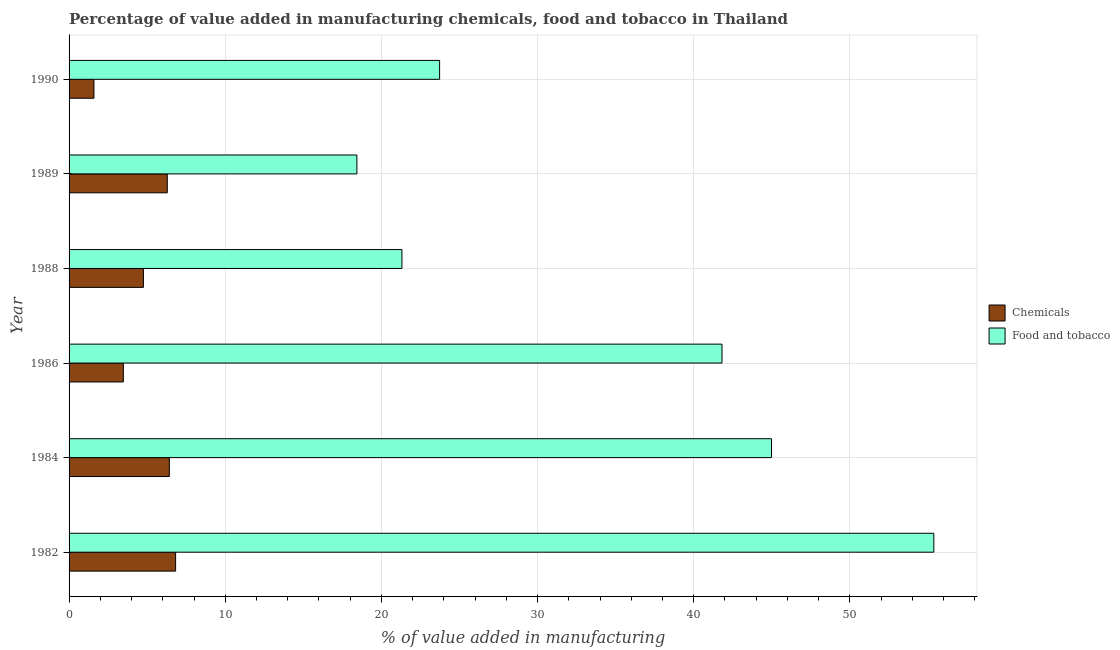How many different coloured bars are there?
Offer a very short reply. 2. Are the number of bars per tick equal to the number of legend labels?
Make the answer very short. Yes. How many bars are there on the 4th tick from the top?
Ensure brevity in your answer.  2. In how many cases, is the number of bars for a given year not equal to the number of legend labels?
Ensure brevity in your answer.  0. What is the value added by manufacturing food and tobacco in 1982?
Make the answer very short. 55.37. Across all years, what is the maximum value added by  manufacturing chemicals?
Keep it short and to the point. 6.82. Across all years, what is the minimum value added by  manufacturing chemicals?
Offer a very short reply. 1.59. In which year was the value added by  manufacturing chemicals maximum?
Offer a terse response. 1982. What is the total value added by  manufacturing chemicals in the graph?
Keep it short and to the point. 29.36. What is the difference between the value added by manufacturing food and tobacco in 1982 and that in 1988?
Provide a succinct answer. 34.06. What is the difference between the value added by manufacturing food and tobacco in 1984 and the value added by  manufacturing chemicals in 1990?
Make the answer very short. 43.39. What is the average value added by  manufacturing chemicals per year?
Ensure brevity in your answer.  4.89. In the year 1988, what is the difference between the value added by  manufacturing chemicals and value added by manufacturing food and tobacco?
Ensure brevity in your answer.  -16.55. What is the ratio of the value added by  manufacturing chemicals in 1986 to that in 1989?
Keep it short and to the point. 0.55. Is the difference between the value added by manufacturing food and tobacco in 1986 and 1988 greater than the difference between the value added by  manufacturing chemicals in 1986 and 1988?
Ensure brevity in your answer.  Yes. What is the difference between the highest and the second highest value added by  manufacturing chemicals?
Give a very brief answer. 0.4. What is the difference between the highest and the lowest value added by manufacturing food and tobacco?
Your answer should be compact. 36.94. Is the sum of the value added by  manufacturing chemicals in 1988 and 1990 greater than the maximum value added by manufacturing food and tobacco across all years?
Give a very brief answer. No. What does the 1st bar from the top in 1982 represents?
Give a very brief answer. Food and tobacco. What does the 2nd bar from the bottom in 1990 represents?
Keep it short and to the point. Food and tobacco. Does the graph contain grids?
Provide a succinct answer. Yes. Where does the legend appear in the graph?
Ensure brevity in your answer.  Center right. How many legend labels are there?
Your answer should be compact. 2. What is the title of the graph?
Provide a short and direct response. Percentage of value added in manufacturing chemicals, food and tobacco in Thailand. What is the label or title of the X-axis?
Your answer should be compact. % of value added in manufacturing. What is the % of value added in manufacturing in Chemicals in 1982?
Offer a terse response. 6.82. What is the % of value added in manufacturing in Food and tobacco in 1982?
Offer a very short reply. 55.37. What is the % of value added in manufacturing in Chemicals in 1984?
Provide a succinct answer. 6.42. What is the % of value added in manufacturing in Food and tobacco in 1984?
Make the answer very short. 44.98. What is the % of value added in manufacturing in Chemicals in 1986?
Your answer should be very brief. 3.48. What is the % of value added in manufacturing of Food and tobacco in 1986?
Your response must be concise. 41.81. What is the % of value added in manufacturing in Chemicals in 1988?
Your answer should be very brief. 4.76. What is the % of value added in manufacturing of Food and tobacco in 1988?
Ensure brevity in your answer.  21.31. What is the % of value added in manufacturing of Chemicals in 1989?
Give a very brief answer. 6.29. What is the % of value added in manufacturing of Food and tobacco in 1989?
Provide a succinct answer. 18.43. What is the % of value added in manufacturing of Chemicals in 1990?
Make the answer very short. 1.59. What is the % of value added in manufacturing in Food and tobacco in 1990?
Provide a succinct answer. 23.73. Across all years, what is the maximum % of value added in manufacturing in Chemicals?
Your answer should be very brief. 6.82. Across all years, what is the maximum % of value added in manufacturing in Food and tobacco?
Give a very brief answer. 55.37. Across all years, what is the minimum % of value added in manufacturing in Chemicals?
Keep it short and to the point. 1.59. Across all years, what is the minimum % of value added in manufacturing in Food and tobacco?
Give a very brief answer. 18.43. What is the total % of value added in manufacturing in Chemicals in the graph?
Your answer should be compact. 29.36. What is the total % of value added in manufacturing in Food and tobacco in the graph?
Make the answer very short. 205.63. What is the difference between the % of value added in manufacturing in Chemicals in 1982 and that in 1984?
Keep it short and to the point. 0.4. What is the difference between the % of value added in manufacturing in Food and tobacco in 1982 and that in 1984?
Provide a short and direct response. 10.39. What is the difference between the % of value added in manufacturing in Chemicals in 1982 and that in 1986?
Offer a very short reply. 3.35. What is the difference between the % of value added in manufacturing of Food and tobacco in 1982 and that in 1986?
Keep it short and to the point. 13.57. What is the difference between the % of value added in manufacturing of Chemicals in 1982 and that in 1988?
Provide a short and direct response. 2.06. What is the difference between the % of value added in manufacturing of Food and tobacco in 1982 and that in 1988?
Make the answer very short. 34.06. What is the difference between the % of value added in manufacturing of Chemicals in 1982 and that in 1989?
Provide a succinct answer. 0.53. What is the difference between the % of value added in manufacturing of Food and tobacco in 1982 and that in 1989?
Provide a succinct answer. 36.94. What is the difference between the % of value added in manufacturing of Chemicals in 1982 and that in 1990?
Offer a terse response. 5.23. What is the difference between the % of value added in manufacturing in Food and tobacco in 1982 and that in 1990?
Your response must be concise. 31.65. What is the difference between the % of value added in manufacturing of Chemicals in 1984 and that in 1986?
Ensure brevity in your answer.  2.94. What is the difference between the % of value added in manufacturing of Food and tobacco in 1984 and that in 1986?
Your response must be concise. 3.17. What is the difference between the % of value added in manufacturing in Chemicals in 1984 and that in 1988?
Offer a very short reply. 1.66. What is the difference between the % of value added in manufacturing in Food and tobacco in 1984 and that in 1988?
Provide a succinct answer. 23.67. What is the difference between the % of value added in manufacturing in Chemicals in 1984 and that in 1989?
Offer a terse response. 0.13. What is the difference between the % of value added in manufacturing in Food and tobacco in 1984 and that in 1989?
Offer a terse response. 26.55. What is the difference between the % of value added in manufacturing in Chemicals in 1984 and that in 1990?
Your answer should be compact. 4.83. What is the difference between the % of value added in manufacturing in Food and tobacco in 1984 and that in 1990?
Offer a terse response. 21.25. What is the difference between the % of value added in manufacturing of Chemicals in 1986 and that in 1988?
Your answer should be compact. -1.28. What is the difference between the % of value added in manufacturing of Food and tobacco in 1986 and that in 1988?
Your answer should be very brief. 20.49. What is the difference between the % of value added in manufacturing of Chemicals in 1986 and that in 1989?
Your response must be concise. -2.81. What is the difference between the % of value added in manufacturing of Food and tobacco in 1986 and that in 1989?
Your response must be concise. 23.38. What is the difference between the % of value added in manufacturing in Chemicals in 1986 and that in 1990?
Keep it short and to the point. 1.88. What is the difference between the % of value added in manufacturing in Food and tobacco in 1986 and that in 1990?
Keep it short and to the point. 18.08. What is the difference between the % of value added in manufacturing of Chemicals in 1988 and that in 1989?
Provide a succinct answer. -1.53. What is the difference between the % of value added in manufacturing in Food and tobacco in 1988 and that in 1989?
Keep it short and to the point. 2.88. What is the difference between the % of value added in manufacturing of Chemicals in 1988 and that in 1990?
Your answer should be very brief. 3.17. What is the difference between the % of value added in manufacturing of Food and tobacco in 1988 and that in 1990?
Make the answer very short. -2.41. What is the difference between the % of value added in manufacturing of Chemicals in 1989 and that in 1990?
Your answer should be very brief. 4.7. What is the difference between the % of value added in manufacturing of Food and tobacco in 1989 and that in 1990?
Your response must be concise. -5.3. What is the difference between the % of value added in manufacturing of Chemicals in 1982 and the % of value added in manufacturing of Food and tobacco in 1984?
Your answer should be compact. -38.16. What is the difference between the % of value added in manufacturing in Chemicals in 1982 and the % of value added in manufacturing in Food and tobacco in 1986?
Your response must be concise. -34.99. What is the difference between the % of value added in manufacturing of Chemicals in 1982 and the % of value added in manufacturing of Food and tobacco in 1988?
Make the answer very short. -14.49. What is the difference between the % of value added in manufacturing in Chemicals in 1982 and the % of value added in manufacturing in Food and tobacco in 1989?
Provide a succinct answer. -11.61. What is the difference between the % of value added in manufacturing in Chemicals in 1982 and the % of value added in manufacturing in Food and tobacco in 1990?
Keep it short and to the point. -16.9. What is the difference between the % of value added in manufacturing of Chemicals in 1984 and the % of value added in manufacturing of Food and tobacco in 1986?
Your response must be concise. -35.39. What is the difference between the % of value added in manufacturing in Chemicals in 1984 and the % of value added in manufacturing in Food and tobacco in 1988?
Provide a short and direct response. -14.89. What is the difference between the % of value added in manufacturing of Chemicals in 1984 and the % of value added in manufacturing of Food and tobacco in 1989?
Offer a very short reply. -12.01. What is the difference between the % of value added in manufacturing in Chemicals in 1984 and the % of value added in manufacturing in Food and tobacco in 1990?
Your response must be concise. -17.31. What is the difference between the % of value added in manufacturing of Chemicals in 1986 and the % of value added in manufacturing of Food and tobacco in 1988?
Give a very brief answer. -17.84. What is the difference between the % of value added in manufacturing of Chemicals in 1986 and the % of value added in manufacturing of Food and tobacco in 1989?
Ensure brevity in your answer.  -14.95. What is the difference between the % of value added in manufacturing in Chemicals in 1986 and the % of value added in manufacturing in Food and tobacco in 1990?
Make the answer very short. -20.25. What is the difference between the % of value added in manufacturing in Chemicals in 1988 and the % of value added in manufacturing in Food and tobacco in 1989?
Offer a terse response. -13.67. What is the difference between the % of value added in manufacturing in Chemicals in 1988 and the % of value added in manufacturing in Food and tobacco in 1990?
Your response must be concise. -18.97. What is the difference between the % of value added in manufacturing of Chemicals in 1989 and the % of value added in manufacturing of Food and tobacco in 1990?
Your answer should be compact. -17.44. What is the average % of value added in manufacturing in Chemicals per year?
Provide a succinct answer. 4.89. What is the average % of value added in manufacturing of Food and tobacco per year?
Your response must be concise. 34.27. In the year 1982, what is the difference between the % of value added in manufacturing of Chemicals and % of value added in manufacturing of Food and tobacco?
Ensure brevity in your answer.  -48.55. In the year 1984, what is the difference between the % of value added in manufacturing in Chemicals and % of value added in manufacturing in Food and tobacco?
Keep it short and to the point. -38.56. In the year 1986, what is the difference between the % of value added in manufacturing in Chemicals and % of value added in manufacturing in Food and tobacco?
Keep it short and to the point. -38.33. In the year 1988, what is the difference between the % of value added in manufacturing of Chemicals and % of value added in manufacturing of Food and tobacco?
Give a very brief answer. -16.55. In the year 1989, what is the difference between the % of value added in manufacturing in Chemicals and % of value added in manufacturing in Food and tobacco?
Keep it short and to the point. -12.14. In the year 1990, what is the difference between the % of value added in manufacturing of Chemicals and % of value added in manufacturing of Food and tobacco?
Provide a succinct answer. -22.13. What is the ratio of the % of value added in manufacturing of Chemicals in 1982 to that in 1984?
Give a very brief answer. 1.06. What is the ratio of the % of value added in manufacturing in Food and tobacco in 1982 to that in 1984?
Your response must be concise. 1.23. What is the ratio of the % of value added in manufacturing in Chemicals in 1982 to that in 1986?
Your answer should be very brief. 1.96. What is the ratio of the % of value added in manufacturing of Food and tobacco in 1982 to that in 1986?
Provide a succinct answer. 1.32. What is the ratio of the % of value added in manufacturing of Chemicals in 1982 to that in 1988?
Keep it short and to the point. 1.43. What is the ratio of the % of value added in manufacturing in Food and tobacco in 1982 to that in 1988?
Give a very brief answer. 2.6. What is the ratio of the % of value added in manufacturing of Chemicals in 1982 to that in 1989?
Provide a short and direct response. 1.08. What is the ratio of the % of value added in manufacturing in Food and tobacco in 1982 to that in 1989?
Make the answer very short. 3. What is the ratio of the % of value added in manufacturing of Chemicals in 1982 to that in 1990?
Offer a terse response. 4.28. What is the ratio of the % of value added in manufacturing of Food and tobacco in 1982 to that in 1990?
Ensure brevity in your answer.  2.33. What is the ratio of the % of value added in manufacturing of Chemicals in 1984 to that in 1986?
Offer a very short reply. 1.85. What is the ratio of the % of value added in manufacturing of Food and tobacco in 1984 to that in 1986?
Provide a succinct answer. 1.08. What is the ratio of the % of value added in manufacturing in Chemicals in 1984 to that in 1988?
Offer a terse response. 1.35. What is the ratio of the % of value added in manufacturing in Food and tobacco in 1984 to that in 1988?
Offer a very short reply. 2.11. What is the ratio of the % of value added in manufacturing of Food and tobacco in 1984 to that in 1989?
Keep it short and to the point. 2.44. What is the ratio of the % of value added in manufacturing of Chemicals in 1984 to that in 1990?
Give a very brief answer. 4.03. What is the ratio of the % of value added in manufacturing in Food and tobacco in 1984 to that in 1990?
Give a very brief answer. 1.9. What is the ratio of the % of value added in manufacturing in Chemicals in 1986 to that in 1988?
Provide a short and direct response. 0.73. What is the ratio of the % of value added in manufacturing in Food and tobacco in 1986 to that in 1988?
Keep it short and to the point. 1.96. What is the ratio of the % of value added in manufacturing of Chemicals in 1986 to that in 1989?
Your answer should be compact. 0.55. What is the ratio of the % of value added in manufacturing of Food and tobacco in 1986 to that in 1989?
Offer a very short reply. 2.27. What is the ratio of the % of value added in manufacturing in Chemicals in 1986 to that in 1990?
Give a very brief answer. 2.18. What is the ratio of the % of value added in manufacturing of Food and tobacco in 1986 to that in 1990?
Your answer should be compact. 1.76. What is the ratio of the % of value added in manufacturing of Chemicals in 1988 to that in 1989?
Your response must be concise. 0.76. What is the ratio of the % of value added in manufacturing of Food and tobacco in 1988 to that in 1989?
Your answer should be very brief. 1.16. What is the ratio of the % of value added in manufacturing in Chemicals in 1988 to that in 1990?
Your answer should be compact. 2.99. What is the ratio of the % of value added in manufacturing in Food and tobacco in 1988 to that in 1990?
Ensure brevity in your answer.  0.9. What is the ratio of the % of value added in manufacturing of Chemicals in 1989 to that in 1990?
Your response must be concise. 3.95. What is the ratio of the % of value added in manufacturing of Food and tobacco in 1989 to that in 1990?
Offer a very short reply. 0.78. What is the difference between the highest and the second highest % of value added in manufacturing of Chemicals?
Provide a short and direct response. 0.4. What is the difference between the highest and the second highest % of value added in manufacturing in Food and tobacco?
Provide a short and direct response. 10.39. What is the difference between the highest and the lowest % of value added in manufacturing in Chemicals?
Keep it short and to the point. 5.23. What is the difference between the highest and the lowest % of value added in manufacturing of Food and tobacco?
Keep it short and to the point. 36.94. 